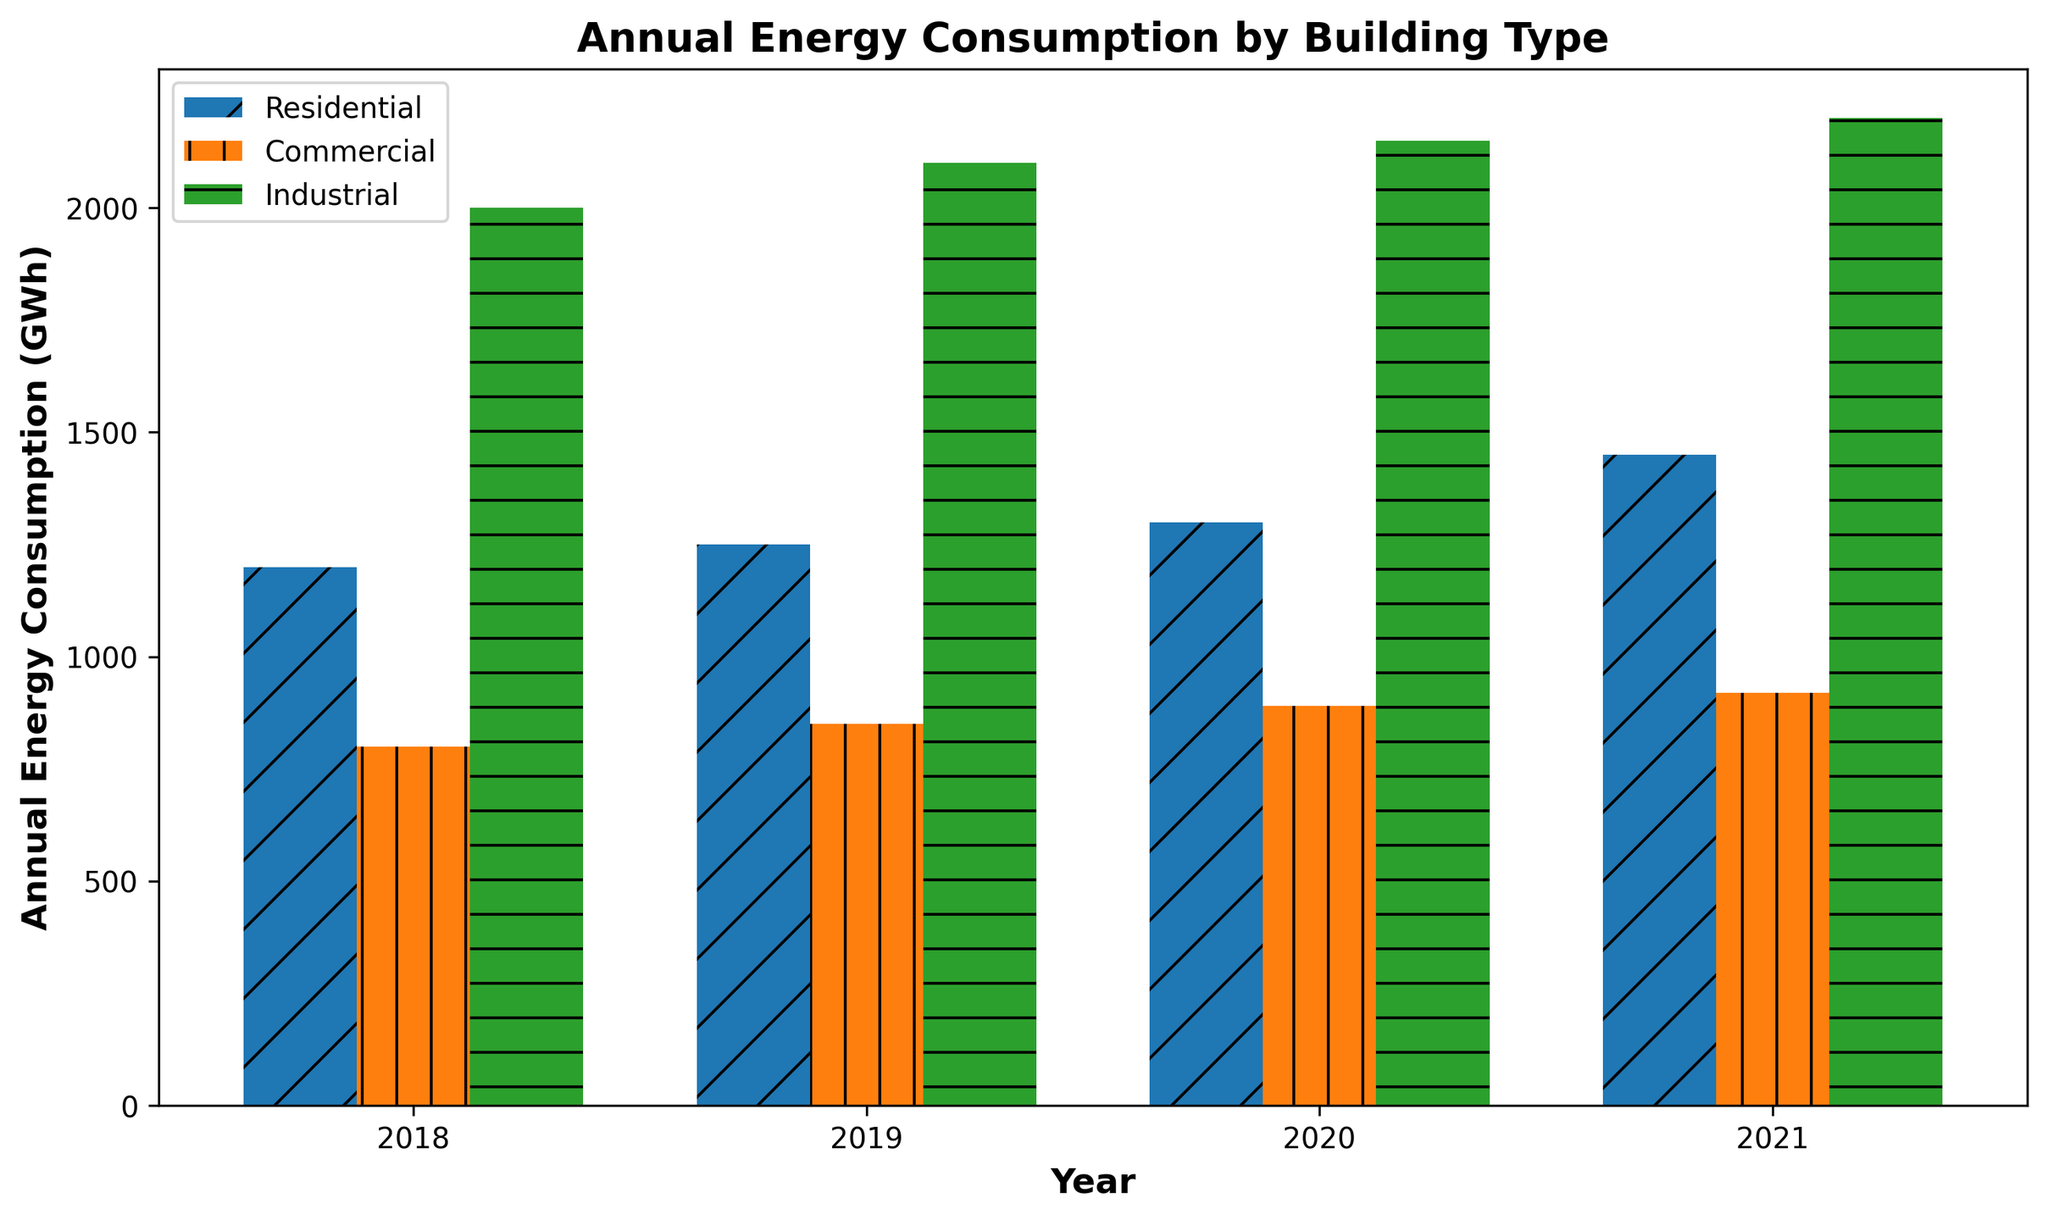What year had the highest annual energy consumption for Residential buildings? To determine the highest annual energy consumption for Residential buildings, look at the bar heights in the Residential category. The tallest bar for Residential corresponds to the year 2021.
Answer: 2021 How much more energy did Industrial buildings consume in 2021 compared to Commercial buildings in the same year? First, find the annual energy consumption for Industrial and Commercial buildings in 2021 by locating the corresponding bars. The Industrial bar height is 2200 GWh, and the Commercial bar height is 920 GWh. Subtract the Commercial value from the Industrial value: 2200 - 920 = 1280 GWh.
Answer: 1280 GWh Which building type had the least energy consumption in 2018? Compare the heights of the bars for the year 2018 among the three building types. The shortest bar belongs to the Commercial buildings with 800 GWh.
Answer: Commercial What is the average annual energy consumption for Residential buildings from 2018 to 2021? The annual energy consumption values for Residential buildings from 2018 to 2021 are 1200, 1250, 1300, and 1450 GWh. Calculate the average: (1200 + 1250 + 1300 + 1450) / 4 = 5200 / 4 = 1300 GWh.
Answer: 1300 GWh Is the energy consumption trend for Industrial buildings increasing, decreasing, or stable from 2018 to 2021? Observe the bar heights for Industrial buildings over the years 2018 to 2021. The bars show an increasing trend: 2000 GWh in 2018, 2100 GWh in 2019, 2150 GWh in 2020, and 2200 GWh in 2021.
Answer: Increasing Compare the energy consumption between Residential and Commercial buildings in 2020. Which one is higher and by how much? Look at the bars for Residential and Commercial buildings for the year 2020. The Residential bar is at 1300 GWh, and the Commercial bar is at 890 GWh. Residential is higher, and the difference is 1300 - 890 = 410 GWh.
Answer: Residential, 410 GWh What is the combined energy consumption for all building types in 2019? Sum the energy consumption values for all building types in 2019: Residential (1250 GWh) + Commercial (850 GWh) + Industrial (2100 GWh). The combined total is 1250 + 850 + 2100 = 4200 GWh.
Answer: 4200 GWh Which building type showed the largest increase in annual energy consumption from 2018 to 2021? Calculate the increase in annual energy consumption from 2018 to 2021 for each building type: 
Residential: 1450 - 1200 = 250 GWh 
Commercial: 920 - 800 = 120 GWh 
Industrial: 2200 - 2000 = 200 GWh. 
The largest increase is for Residential buildings (250 GWh).
Answer: Residential 